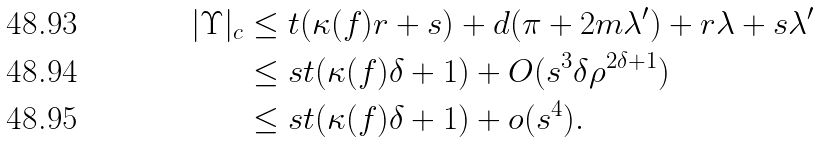Convert formula to latex. <formula><loc_0><loc_0><loc_500><loc_500>| \Upsilon | _ { c } & \leq t ( \kappa ( f ) r + s ) + d ( \pi + 2 m \lambda ^ { \prime } ) + r \lambda + s \lambda ^ { \prime } \\ & \leq s t ( \kappa ( f ) \delta + 1 ) + O ( s ^ { 3 } \delta \rho ^ { 2 \delta + 1 } ) \\ & \leq s t ( \kappa ( f ) \delta + 1 ) + o ( s ^ { 4 } ) .</formula> 